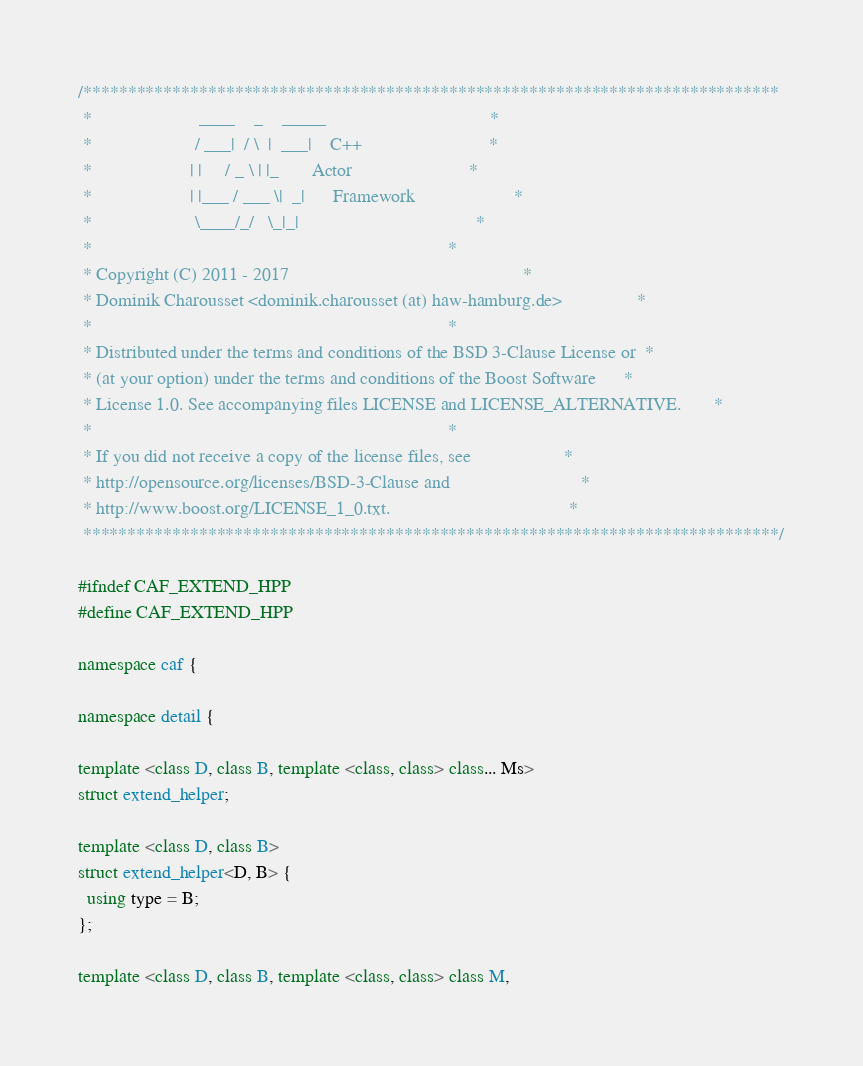Convert code to text. <code><loc_0><loc_0><loc_500><loc_500><_C++_>/******************************************************************************
 *                       ____    _    _____                                   *
 *                      / ___|  / \  |  ___|    C++                           *
 *                     | |     / _ \ | |_       Actor                         *
 *                     | |___ / ___ \|  _|      Framework                     *
 *                      \____/_/   \_|_|                                      *
 *                                                                            *
 * Copyright (C) 2011 - 2017                                                  *
 * Dominik Charousset <dominik.charousset (at) haw-hamburg.de>                *
 *                                                                            *
 * Distributed under the terms and conditions of the BSD 3-Clause License or  *
 * (at your option) under the terms and conditions of the Boost Software      *
 * License 1.0. See accompanying files LICENSE and LICENSE_ALTERNATIVE.       *
 *                                                                            *
 * If you did not receive a copy of the license files, see                    *
 * http://opensource.org/licenses/BSD-3-Clause and                            *
 * http://www.boost.org/LICENSE_1_0.txt.                                      *
 ******************************************************************************/

#ifndef CAF_EXTEND_HPP
#define CAF_EXTEND_HPP

namespace caf {

namespace detail {

template <class D, class B, template <class, class> class... Ms>
struct extend_helper;

template <class D, class B>
struct extend_helper<D, B> {
  using type = B;
};

template <class D, class B, template <class, class> class M,</code> 